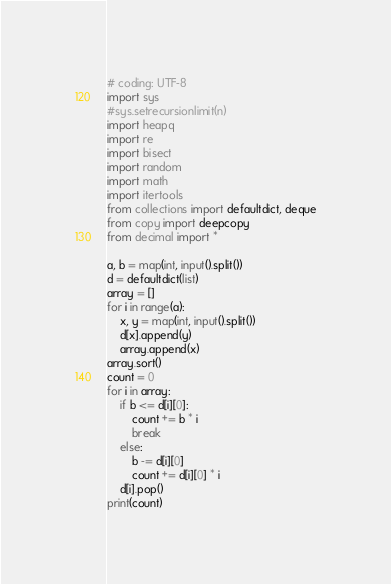<code> <loc_0><loc_0><loc_500><loc_500><_Python_># coding: UTF-8
import sys
#sys.setrecursionlimit(n)
import heapq
import re
import bisect
import random
import math
import itertools
from collections import defaultdict, deque
from copy import deepcopy
from decimal import *

a, b = map(int, input().split())
d = defaultdict(list)
array = []
for i in range(a):
    x, y = map(int, input().split())
    d[x].append(y)
    array.append(x)
array.sort()
count = 0
for i in array:
    if b <= d[i][0]:
        count += b * i
        break
    else:
        b -= d[i][0]
        count += d[i][0] * i
    d[i].pop()
print(count)</code> 